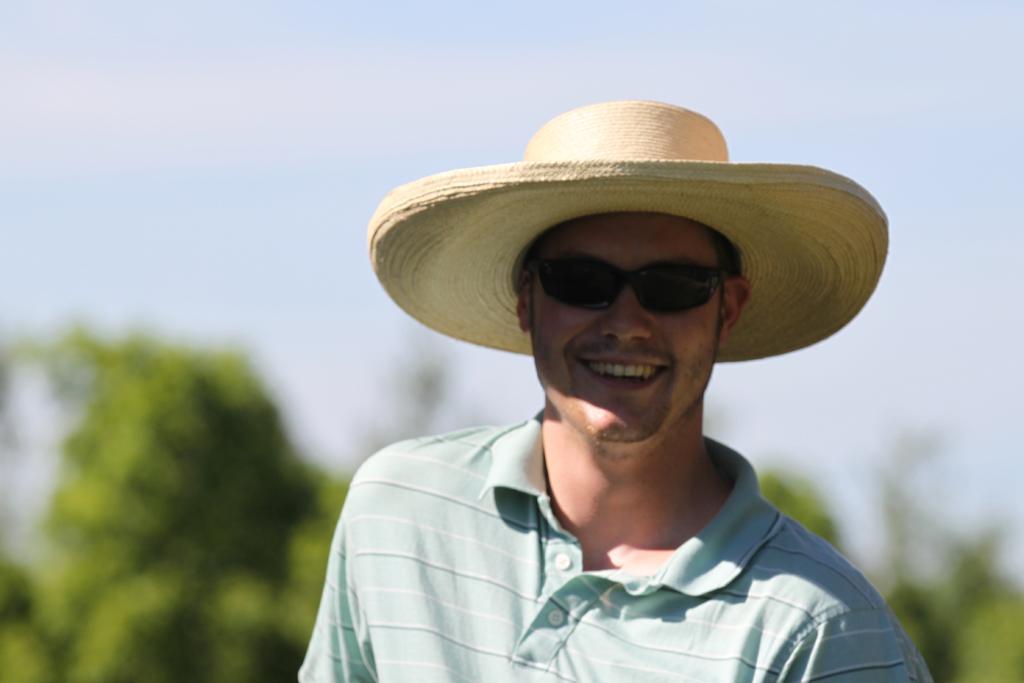Describe this image in one or two sentences. In this image we can see a person wearing a hat and glasses. On the backside we can see some plants and the sky. 